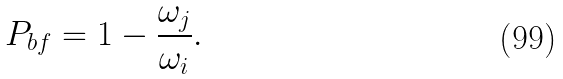Convert formula to latex. <formula><loc_0><loc_0><loc_500><loc_500>P _ { b f } = 1 - \frac { \omega _ { j } } { \omega _ { i } } .</formula> 